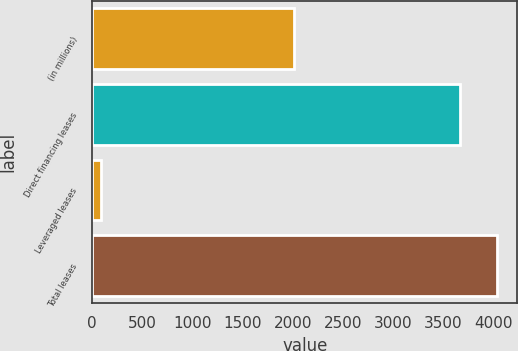<chart> <loc_0><loc_0><loc_500><loc_500><bar_chart><fcel>(in millions)<fcel>Direct financing leases<fcel>Leveraged leases<fcel>Total leases<nl><fcel>2016<fcel>3670<fcel>83<fcel>4037<nl></chart> 